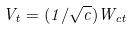Convert formula to latex. <formula><loc_0><loc_0><loc_500><loc_500>V _ { t } = ( 1 / \sqrt { c } ) W _ { c t }</formula> 